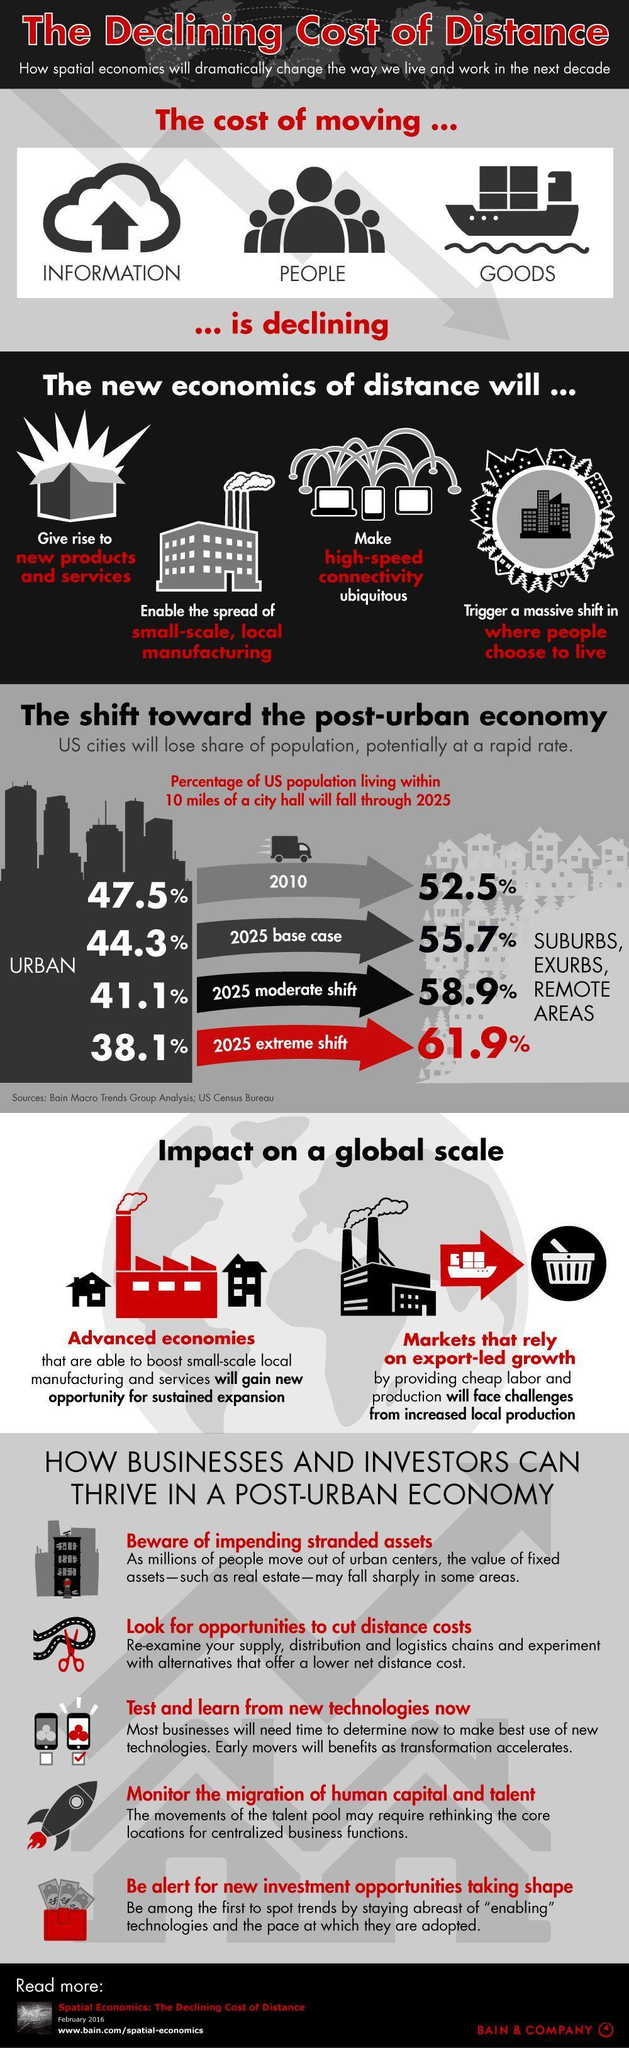What is the second tip listed to help businesses grow in a post-urban economy?
Answer the question with a short phrase. look for opportunities to cut distance costs Which area is expected to have a lesser population by 2025 - urban or suburbs? urban Who will face challenges from increased local production in a post-urban economy? markets that rely on export-led growth Who will gain new opportunities for sustained expansion in a post-urban economy? Advanced economies To which areas are most people likely to shift by the year 2025? suburbs, exurbs, remote areas 